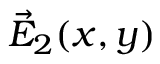<formula> <loc_0><loc_0><loc_500><loc_500>\vec { E } _ { 2 } ( x , y )</formula> 